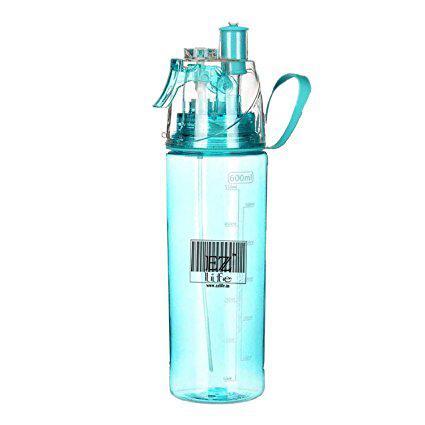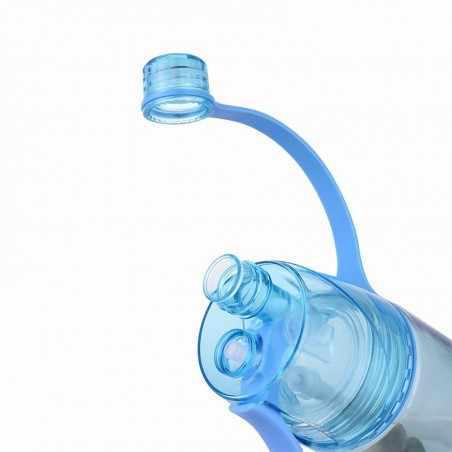The first image is the image on the left, the second image is the image on the right. Analyze the images presented: Is the assertion "There are exactly two bottles." valid? Answer yes or no. Yes. The first image is the image on the left, the second image is the image on the right. Considering the images on both sides, is "One of the bottles is closed and has a straw down the middle, a loop on the side, and a trigger on the opposite side." valid? Answer yes or no. Yes. 